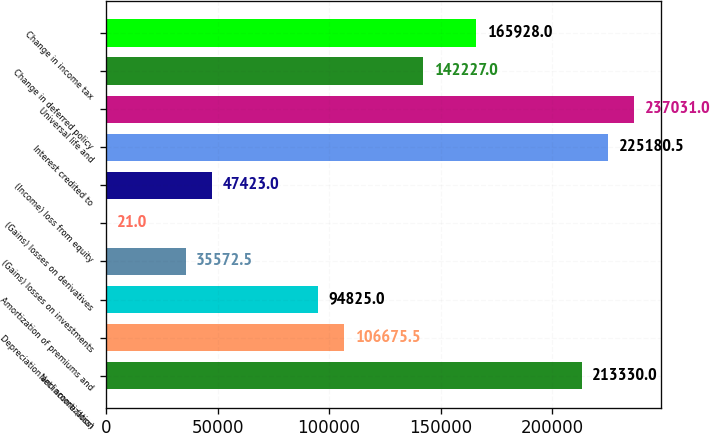Convert chart. <chart><loc_0><loc_0><loc_500><loc_500><bar_chart><fcel>Net income (loss)<fcel>Depreciation and amortization<fcel>Amortization of premiums and<fcel>(Gains) losses on investments<fcel>(Gains) losses on derivatives<fcel>(Income) loss from equity<fcel>Interest credited to<fcel>Universal life and<fcel>Change in deferred policy<fcel>Change in income tax<nl><fcel>213330<fcel>106676<fcel>94825<fcel>35572.5<fcel>21<fcel>47423<fcel>225180<fcel>237031<fcel>142227<fcel>165928<nl></chart> 